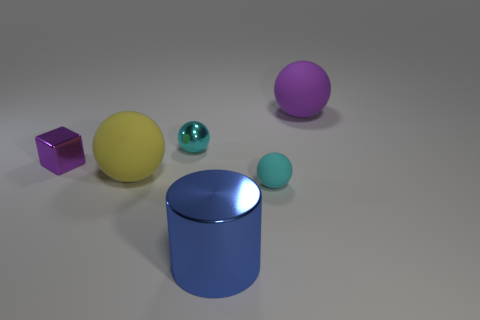Which object in the image appears to be the largest? The object that appears to be the largest in the image is the purple ball situated on the right side. What can you say about the lighting in the scene? The lighting in the scene casts soft shadows and indicates an indirect light source, producing a diffuse and soft illumination without harsh contrasts or strong directional shadows. 